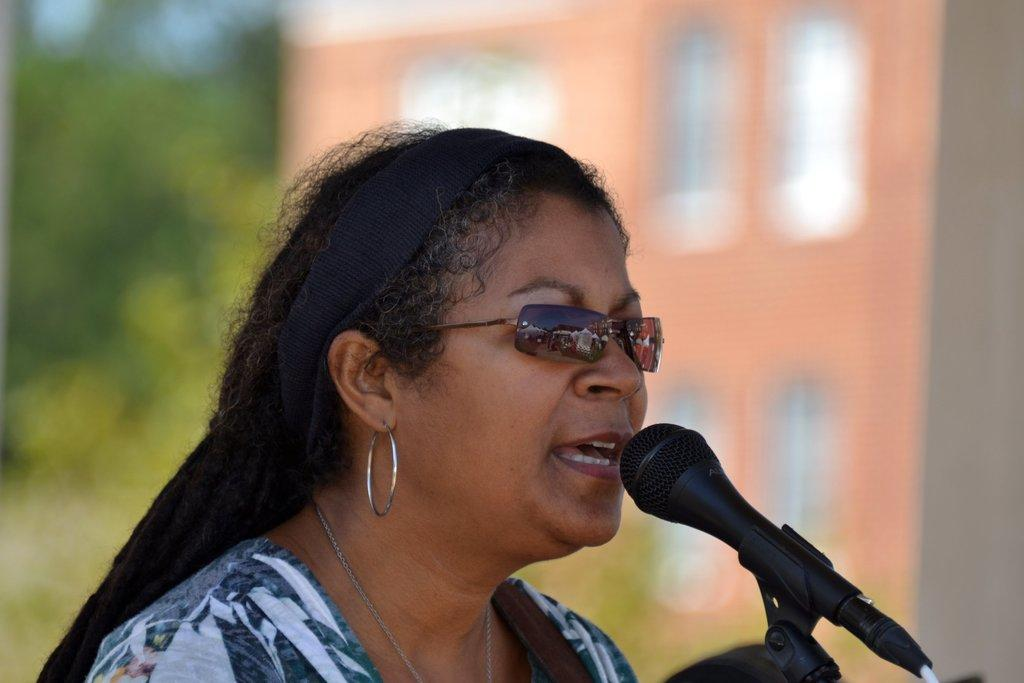Who is present in the image? There is a woman in the image. What is the woman wearing? The woman is wearing spectacles. What is the woman doing in the image? The woman is speaking. What object is on the right side of the image? There is a microphone on the right side of the image. What can be seen in the background of the image? The background of the image is blurred. What type of vegetation is visible on the left side of the image? There is greenery on the left side of the image. Can you see any bun in the image? There is no bun present in the image. Is there a stream visible in the image? There is no stream visible in the image. 